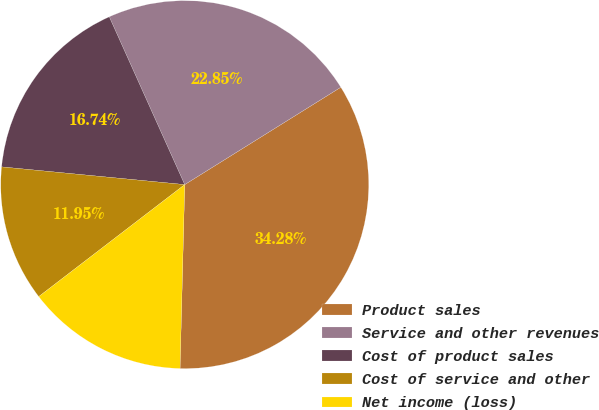Convert chart. <chart><loc_0><loc_0><loc_500><loc_500><pie_chart><fcel>Product sales<fcel>Service and other revenues<fcel>Cost of product sales<fcel>Cost of service and other<fcel>Net income (loss)<nl><fcel>34.28%<fcel>22.85%<fcel>16.74%<fcel>11.95%<fcel>14.18%<nl></chart> 